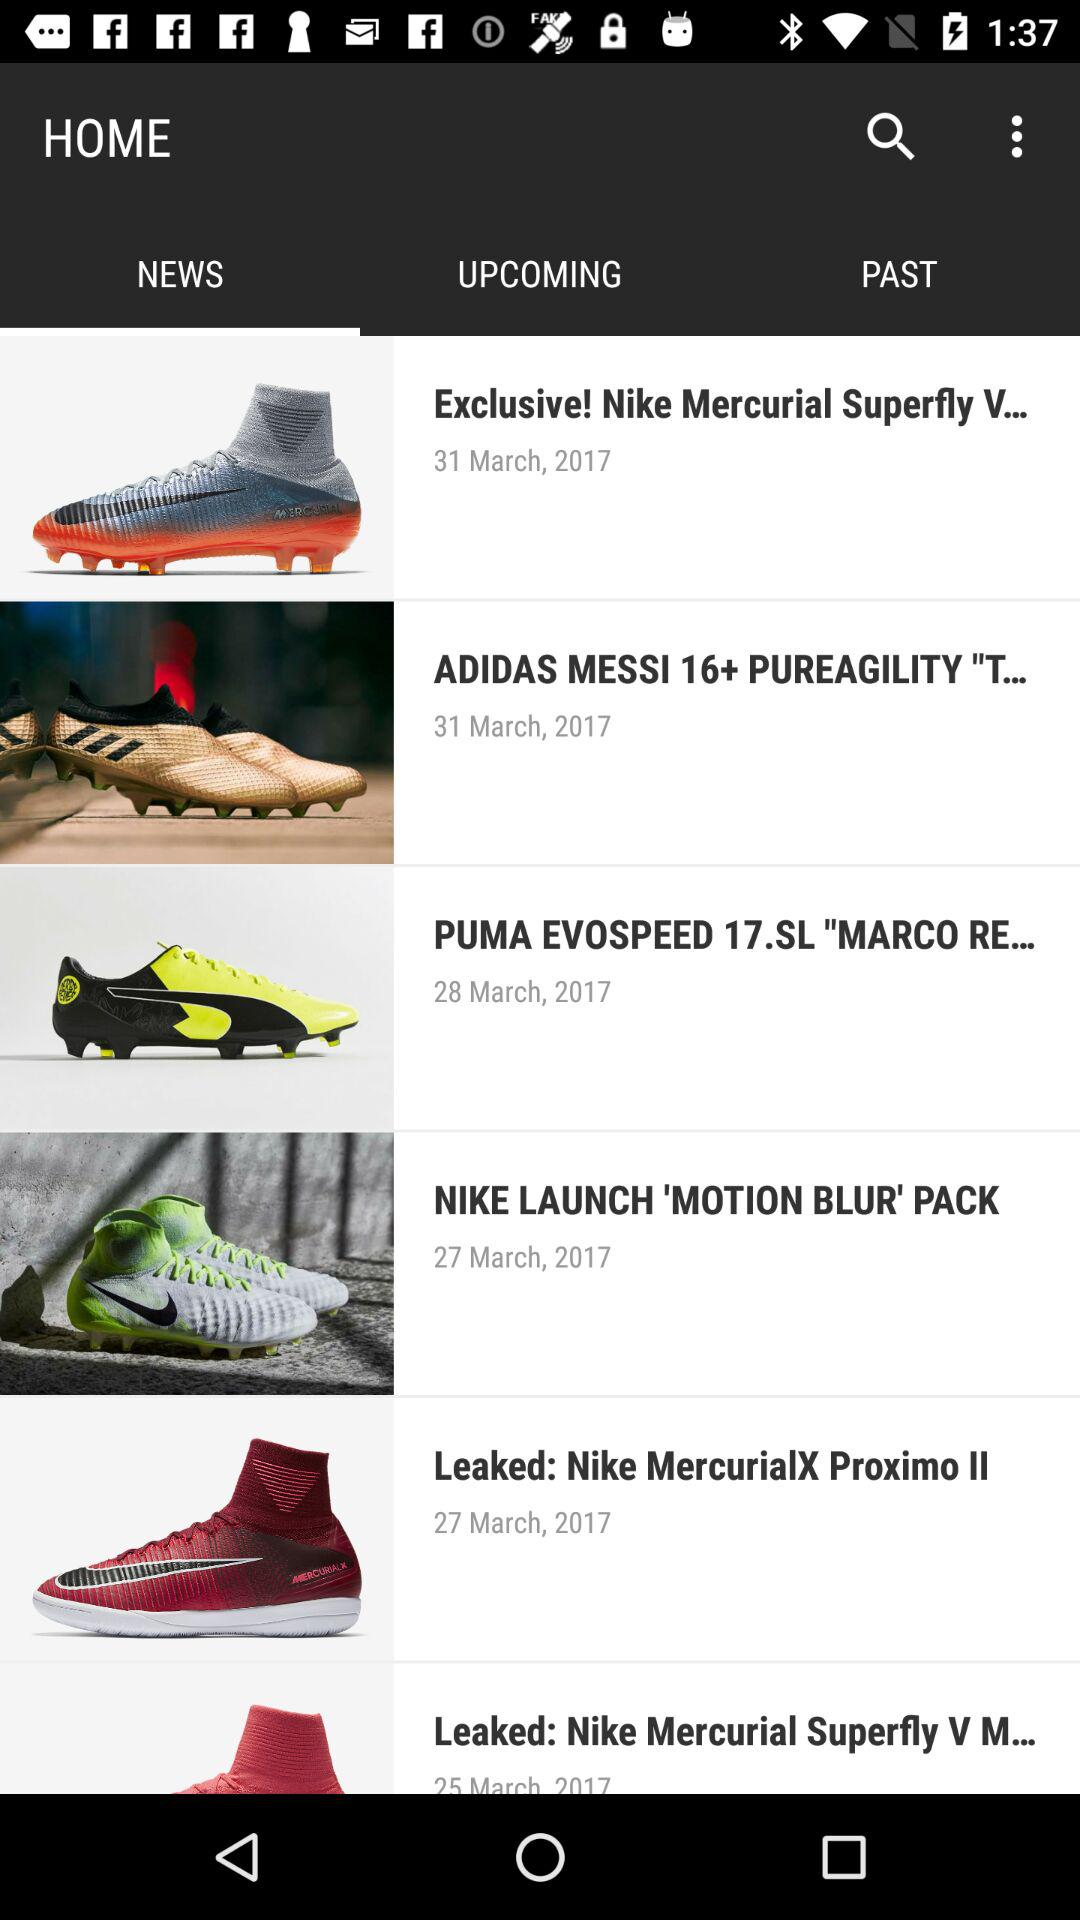When was the "'MOTION BLUR' PACK" released by Nike? It was released on March 27, 2017. 